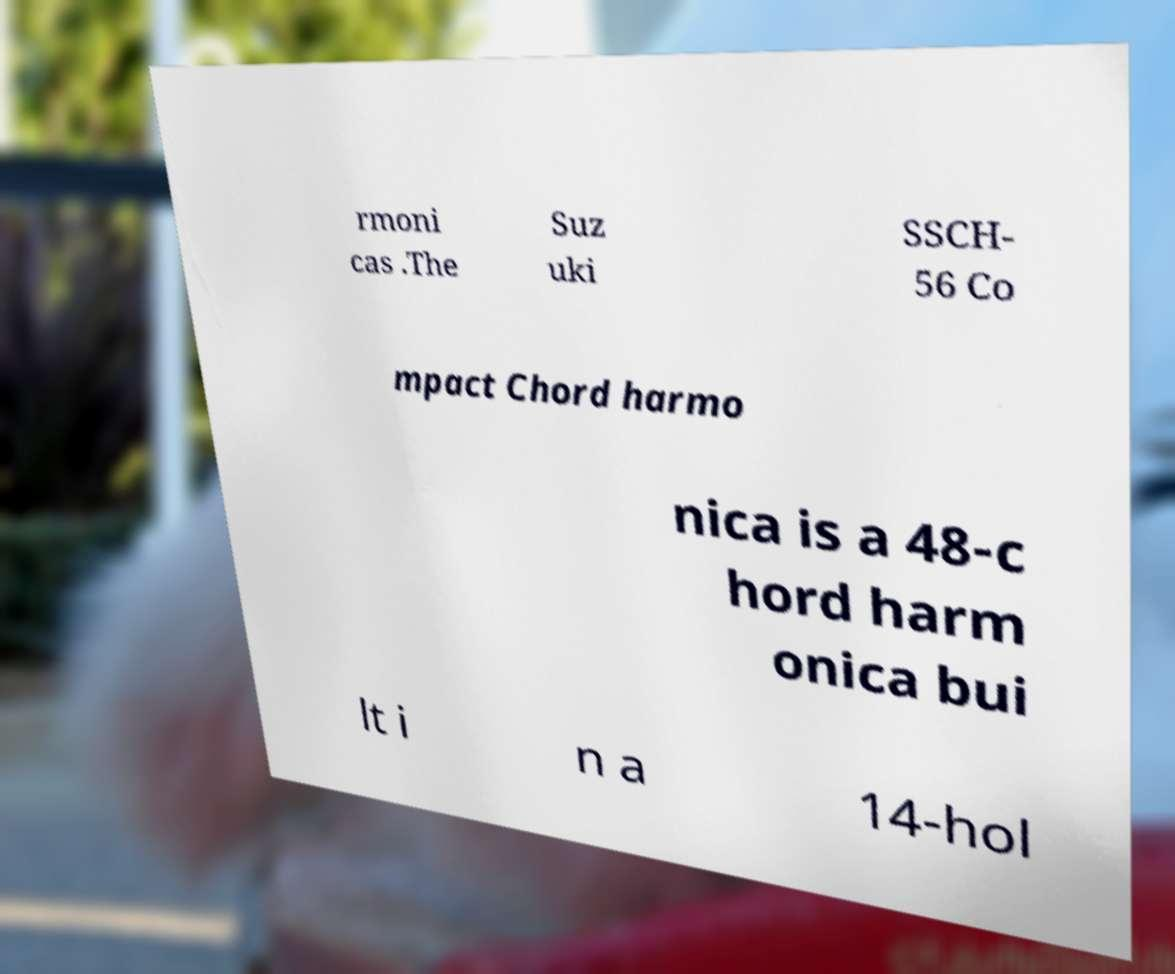I need the written content from this picture converted into text. Can you do that? rmoni cas .The Suz uki SSCH- 56 Co mpact Chord harmo nica is a 48-c hord harm onica bui lt i n a 14-hol 